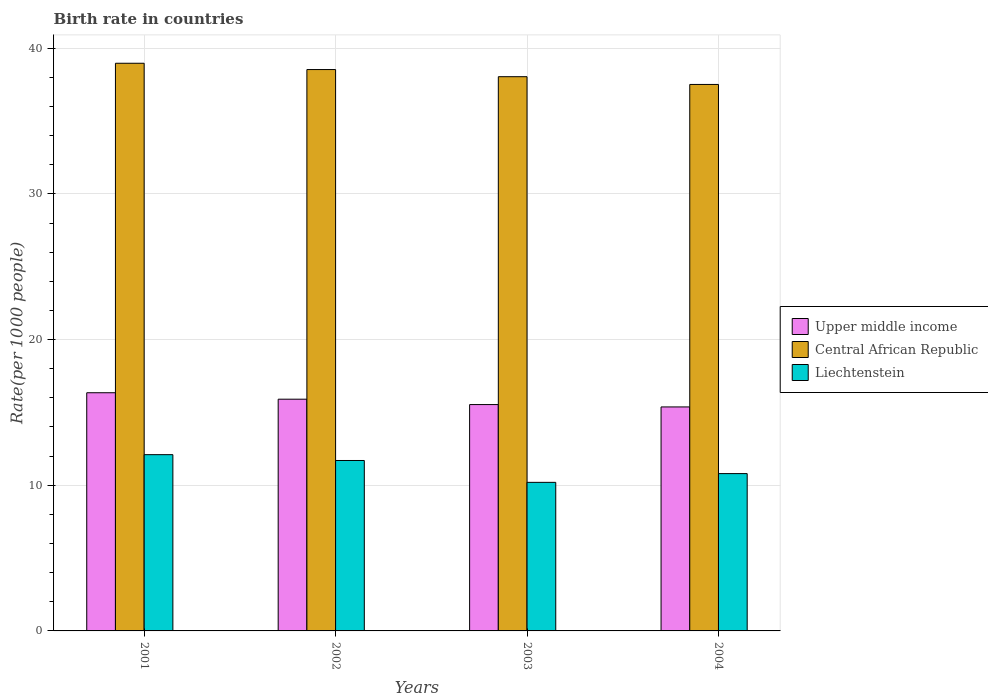How many different coloured bars are there?
Your response must be concise. 3. Are the number of bars per tick equal to the number of legend labels?
Provide a short and direct response. Yes. How many bars are there on the 4th tick from the right?
Ensure brevity in your answer.  3. In how many cases, is the number of bars for a given year not equal to the number of legend labels?
Make the answer very short. 0. In which year was the birth rate in Liechtenstein minimum?
Keep it short and to the point. 2003. What is the total birth rate in Central African Republic in the graph?
Your response must be concise. 153.07. What is the difference between the birth rate in Upper middle income in 2003 and that in 2004?
Your answer should be compact. 0.16. What is the difference between the birth rate in Liechtenstein in 2003 and the birth rate in Central African Republic in 2004?
Give a very brief answer. -27.32. In the year 2004, what is the difference between the birth rate in Central African Republic and birth rate in Liechtenstein?
Provide a succinct answer. 26.72. What is the ratio of the birth rate in Central African Republic in 2001 to that in 2002?
Make the answer very short. 1.01. Is the birth rate in Central African Republic in 2003 less than that in 2004?
Your answer should be very brief. No. What is the difference between the highest and the second highest birth rate in Central African Republic?
Keep it short and to the point. 0.43. What is the difference between the highest and the lowest birth rate in Upper middle income?
Provide a short and direct response. 0.97. What does the 3rd bar from the left in 2001 represents?
Make the answer very short. Liechtenstein. What does the 2nd bar from the right in 2004 represents?
Keep it short and to the point. Central African Republic. Are all the bars in the graph horizontal?
Offer a terse response. No. How are the legend labels stacked?
Provide a short and direct response. Vertical. What is the title of the graph?
Keep it short and to the point. Birth rate in countries. Does "Kazakhstan" appear as one of the legend labels in the graph?
Offer a terse response. No. What is the label or title of the X-axis?
Make the answer very short. Years. What is the label or title of the Y-axis?
Offer a terse response. Rate(per 1000 people). What is the Rate(per 1000 people) of Upper middle income in 2001?
Offer a very short reply. 16.35. What is the Rate(per 1000 people) of Central African Republic in 2001?
Give a very brief answer. 38.97. What is the Rate(per 1000 people) of Liechtenstein in 2001?
Make the answer very short. 12.1. What is the Rate(per 1000 people) of Upper middle income in 2002?
Make the answer very short. 15.91. What is the Rate(per 1000 people) of Central African Republic in 2002?
Offer a very short reply. 38.54. What is the Rate(per 1000 people) in Liechtenstein in 2002?
Offer a very short reply. 11.7. What is the Rate(per 1000 people) of Upper middle income in 2003?
Offer a terse response. 15.54. What is the Rate(per 1000 people) of Central African Republic in 2003?
Provide a short and direct response. 38.05. What is the Rate(per 1000 people) of Upper middle income in 2004?
Your response must be concise. 15.38. What is the Rate(per 1000 people) of Central African Republic in 2004?
Your answer should be very brief. 37.52. What is the Rate(per 1000 people) of Liechtenstein in 2004?
Keep it short and to the point. 10.8. Across all years, what is the maximum Rate(per 1000 people) of Upper middle income?
Your answer should be compact. 16.35. Across all years, what is the maximum Rate(per 1000 people) of Central African Republic?
Your answer should be compact. 38.97. Across all years, what is the minimum Rate(per 1000 people) of Upper middle income?
Provide a succinct answer. 15.38. Across all years, what is the minimum Rate(per 1000 people) in Central African Republic?
Keep it short and to the point. 37.52. What is the total Rate(per 1000 people) in Upper middle income in the graph?
Give a very brief answer. 63.18. What is the total Rate(per 1000 people) of Central African Republic in the graph?
Your answer should be very brief. 153.07. What is the total Rate(per 1000 people) in Liechtenstein in the graph?
Offer a terse response. 44.8. What is the difference between the Rate(per 1000 people) of Upper middle income in 2001 and that in 2002?
Give a very brief answer. 0.44. What is the difference between the Rate(per 1000 people) of Central African Republic in 2001 and that in 2002?
Make the answer very short. 0.43. What is the difference between the Rate(per 1000 people) in Liechtenstein in 2001 and that in 2002?
Make the answer very short. 0.4. What is the difference between the Rate(per 1000 people) in Upper middle income in 2001 and that in 2003?
Give a very brief answer. 0.81. What is the difference between the Rate(per 1000 people) in Central African Republic in 2001 and that in 2003?
Your answer should be very brief. 0.92. What is the difference between the Rate(per 1000 people) of Upper middle income in 2001 and that in 2004?
Your answer should be very brief. 0.97. What is the difference between the Rate(per 1000 people) in Central African Republic in 2001 and that in 2004?
Make the answer very short. 1.46. What is the difference between the Rate(per 1000 people) of Upper middle income in 2002 and that in 2003?
Offer a terse response. 0.37. What is the difference between the Rate(per 1000 people) in Central African Republic in 2002 and that in 2003?
Your response must be concise. 0.49. What is the difference between the Rate(per 1000 people) of Liechtenstein in 2002 and that in 2003?
Ensure brevity in your answer.  1.5. What is the difference between the Rate(per 1000 people) in Upper middle income in 2002 and that in 2004?
Provide a short and direct response. 0.53. What is the difference between the Rate(per 1000 people) in Upper middle income in 2003 and that in 2004?
Offer a terse response. 0.16. What is the difference between the Rate(per 1000 people) of Central African Republic in 2003 and that in 2004?
Offer a very short reply. 0.53. What is the difference between the Rate(per 1000 people) in Upper middle income in 2001 and the Rate(per 1000 people) in Central African Republic in 2002?
Give a very brief answer. -22.19. What is the difference between the Rate(per 1000 people) in Upper middle income in 2001 and the Rate(per 1000 people) in Liechtenstein in 2002?
Keep it short and to the point. 4.65. What is the difference between the Rate(per 1000 people) in Central African Republic in 2001 and the Rate(per 1000 people) in Liechtenstein in 2002?
Ensure brevity in your answer.  27.27. What is the difference between the Rate(per 1000 people) in Upper middle income in 2001 and the Rate(per 1000 people) in Central African Republic in 2003?
Make the answer very short. -21.7. What is the difference between the Rate(per 1000 people) of Upper middle income in 2001 and the Rate(per 1000 people) of Liechtenstein in 2003?
Your answer should be very brief. 6.15. What is the difference between the Rate(per 1000 people) in Central African Republic in 2001 and the Rate(per 1000 people) in Liechtenstein in 2003?
Your response must be concise. 28.77. What is the difference between the Rate(per 1000 people) of Upper middle income in 2001 and the Rate(per 1000 people) of Central African Republic in 2004?
Offer a terse response. -21.16. What is the difference between the Rate(per 1000 people) in Upper middle income in 2001 and the Rate(per 1000 people) in Liechtenstein in 2004?
Provide a short and direct response. 5.55. What is the difference between the Rate(per 1000 people) of Central African Republic in 2001 and the Rate(per 1000 people) of Liechtenstein in 2004?
Your response must be concise. 28.17. What is the difference between the Rate(per 1000 people) of Upper middle income in 2002 and the Rate(per 1000 people) of Central African Republic in 2003?
Your answer should be very brief. -22.14. What is the difference between the Rate(per 1000 people) in Upper middle income in 2002 and the Rate(per 1000 people) in Liechtenstein in 2003?
Your answer should be very brief. 5.71. What is the difference between the Rate(per 1000 people) of Central African Republic in 2002 and the Rate(per 1000 people) of Liechtenstein in 2003?
Your response must be concise. 28.34. What is the difference between the Rate(per 1000 people) in Upper middle income in 2002 and the Rate(per 1000 people) in Central African Republic in 2004?
Offer a terse response. -21.61. What is the difference between the Rate(per 1000 people) in Upper middle income in 2002 and the Rate(per 1000 people) in Liechtenstein in 2004?
Give a very brief answer. 5.11. What is the difference between the Rate(per 1000 people) of Central African Republic in 2002 and the Rate(per 1000 people) of Liechtenstein in 2004?
Offer a terse response. 27.74. What is the difference between the Rate(per 1000 people) in Upper middle income in 2003 and the Rate(per 1000 people) in Central African Republic in 2004?
Your answer should be compact. -21.98. What is the difference between the Rate(per 1000 people) in Upper middle income in 2003 and the Rate(per 1000 people) in Liechtenstein in 2004?
Offer a very short reply. 4.74. What is the difference between the Rate(per 1000 people) of Central African Republic in 2003 and the Rate(per 1000 people) of Liechtenstein in 2004?
Offer a terse response. 27.25. What is the average Rate(per 1000 people) of Upper middle income per year?
Offer a very short reply. 15.79. What is the average Rate(per 1000 people) in Central African Republic per year?
Your response must be concise. 38.27. What is the average Rate(per 1000 people) of Liechtenstein per year?
Ensure brevity in your answer.  11.2. In the year 2001, what is the difference between the Rate(per 1000 people) of Upper middle income and Rate(per 1000 people) of Central African Republic?
Your answer should be very brief. -22.62. In the year 2001, what is the difference between the Rate(per 1000 people) in Upper middle income and Rate(per 1000 people) in Liechtenstein?
Provide a short and direct response. 4.25. In the year 2001, what is the difference between the Rate(per 1000 people) in Central African Republic and Rate(per 1000 people) in Liechtenstein?
Your answer should be very brief. 26.87. In the year 2002, what is the difference between the Rate(per 1000 people) of Upper middle income and Rate(per 1000 people) of Central African Republic?
Your answer should be compact. -22.63. In the year 2002, what is the difference between the Rate(per 1000 people) in Upper middle income and Rate(per 1000 people) in Liechtenstein?
Your answer should be compact. 4.21. In the year 2002, what is the difference between the Rate(per 1000 people) of Central African Republic and Rate(per 1000 people) of Liechtenstein?
Your answer should be compact. 26.84. In the year 2003, what is the difference between the Rate(per 1000 people) of Upper middle income and Rate(per 1000 people) of Central African Republic?
Provide a short and direct response. -22.51. In the year 2003, what is the difference between the Rate(per 1000 people) in Upper middle income and Rate(per 1000 people) in Liechtenstein?
Keep it short and to the point. 5.34. In the year 2003, what is the difference between the Rate(per 1000 people) of Central African Republic and Rate(per 1000 people) of Liechtenstein?
Provide a short and direct response. 27.85. In the year 2004, what is the difference between the Rate(per 1000 people) of Upper middle income and Rate(per 1000 people) of Central African Republic?
Provide a short and direct response. -22.14. In the year 2004, what is the difference between the Rate(per 1000 people) in Upper middle income and Rate(per 1000 people) in Liechtenstein?
Provide a succinct answer. 4.58. In the year 2004, what is the difference between the Rate(per 1000 people) in Central African Republic and Rate(per 1000 people) in Liechtenstein?
Make the answer very short. 26.72. What is the ratio of the Rate(per 1000 people) in Upper middle income in 2001 to that in 2002?
Provide a succinct answer. 1.03. What is the ratio of the Rate(per 1000 people) in Central African Republic in 2001 to that in 2002?
Your answer should be very brief. 1.01. What is the ratio of the Rate(per 1000 people) of Liechtenstein in 2001 to that in 2002?
Give a very brief answer. 1.03. What is the ratio of the Rate(per 1000 people) of Upper middle income in 2001 to that in 2003?
Ensure brevity in your answer.  1.05. What is the ratio of the Rate(per 1000 people) of Central African Republic in 2001 to that in 2003?
Ensure brevity in your answer.  1.02. What is the ratio of the Rate(per 1000 people) of Liechtenstein in 2001 to that in 2003?
Provide a short and direct response. 1.19. What is the ratio of the Rate(per 1000 people) of Upper middle income in 2001 to that in 2004?
Provide a succinct answer. 1.06. What is the ratio of the Rate(per 1000 people) of Central African Republic in 2001 to that in 2004?
Ensure brevity in your answer.  1.04. What is the ratio of the Rate(per 1000 people) in Liechtenstein in 2001 to that in 2004?
Offer a very short reply. 1.12. What is the ratio of the Rate(per 1000 people) of Upper middle income in 2002 to that in 2003?
Offer a very short reply. 1.02. What is the ratio of the Rate(per 1000 people) in Central African Republic in 2002 to that in 2003?
Give a very brief answer. 1.01. What is the ratio of the Rate(per 1000 people) of Liechtenstein in 2002 to that in 2003?
Offer a terse response. 1.15. What is the ratio of the Rate(per 1000 people) in Upper middle income in 2002 to that in 2004?
Keep it short and to the point. 1.03. What is the ratio of the Rate(per 1000 people) in Central African Republic in 2002 to that in 2004?
Your response must be concise. 1.03. What is the ratio of the Rate(per 1000 people) in Liechtenstein in 2002 to that in 2004?
Provide a succinct answer. 1.08. What is the ratio of the Rate(per 1000 people) of Upper middle income in 2003 to that in 2004?
Offer a very short reply. 1.01. What is the ratio of the Rate(per 1000 people) in Central African Republic in 2003 to that in 2004?
Offer a terse response. 1.01. What is the ratio of the Rate(per 1000 people) of Liechtenstein in 2003 to that in 2004?
Keep it short and to the point. 0.94. What is the difference between the highest and the second highest Rate(per 1000 people) in Upper middle income?
Give a very brief answer. 0.44. What is the difference between the highest and the second highest Rate(per 1000 people) in Central African Republic?
Provide a succinct answer. 0.43. What is the difference between the highest and the lowest Rate(per 1000 people) of Central African Republic?
Provide a short and direct response. 1.46. What is the difference between the highest and the lowest Rate(per 1000 people) in Liechtenstein?
Provide a short and direct response. 1.9. 